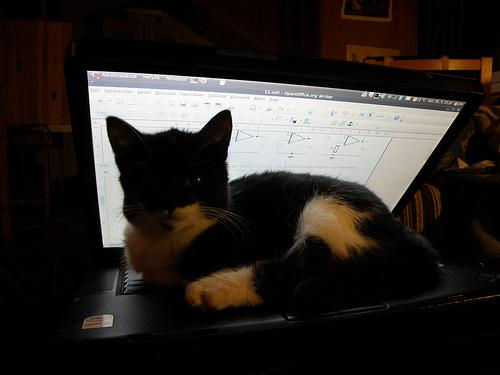Question: what is on the computer?
Choices:
A. Game.
B. The cat.
C. Work.
D. Homework.
Answer with the letter. Answer: B Question: where is the photo taken?
Choices:
A. In the barn.
B. In a house.
C. In the school.
D. In the church.
Answer with the letter. Answer: B Question: when is the photo taken?
Choices:
A. Yesterday.
B. In the morning.
C. One hour ago.
D. Night time.
Answer with the letter. Answer: D 